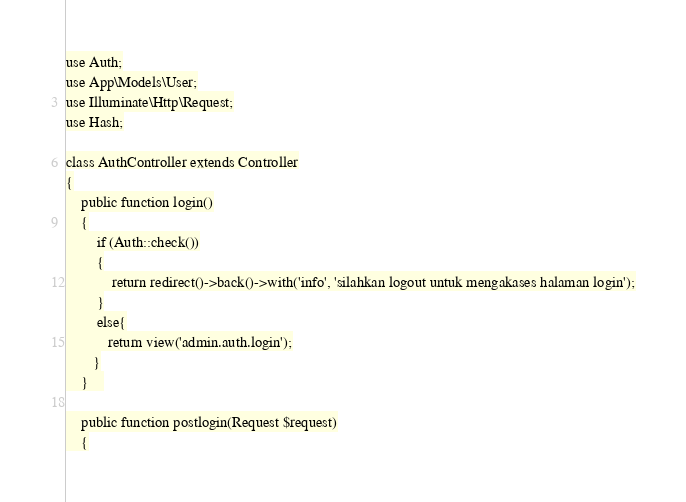<code> <loc_0><loc_0><loc_500><loc_500><_PHP_>
use Auth;
use App\Models\User;
use Illuminate\Http\Request;
use Hash;

class AuthController extends Controller
{
    public function login()
    {
        if (Auth::check())
        {
            return redirect()->back()->with('info', 'silahkan logout untuk mengakases halaman login');
        }
        else{
           return view('admin.auth.login');
       }
    }    

    public function postlogin(Request $request)
    {</code> 